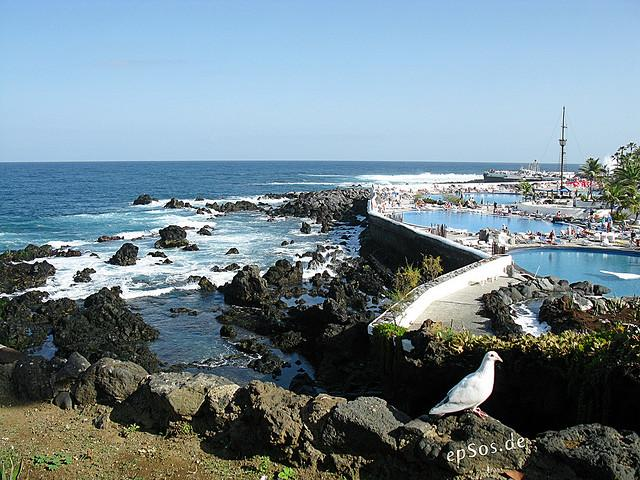What venue is shown on the right? resort 